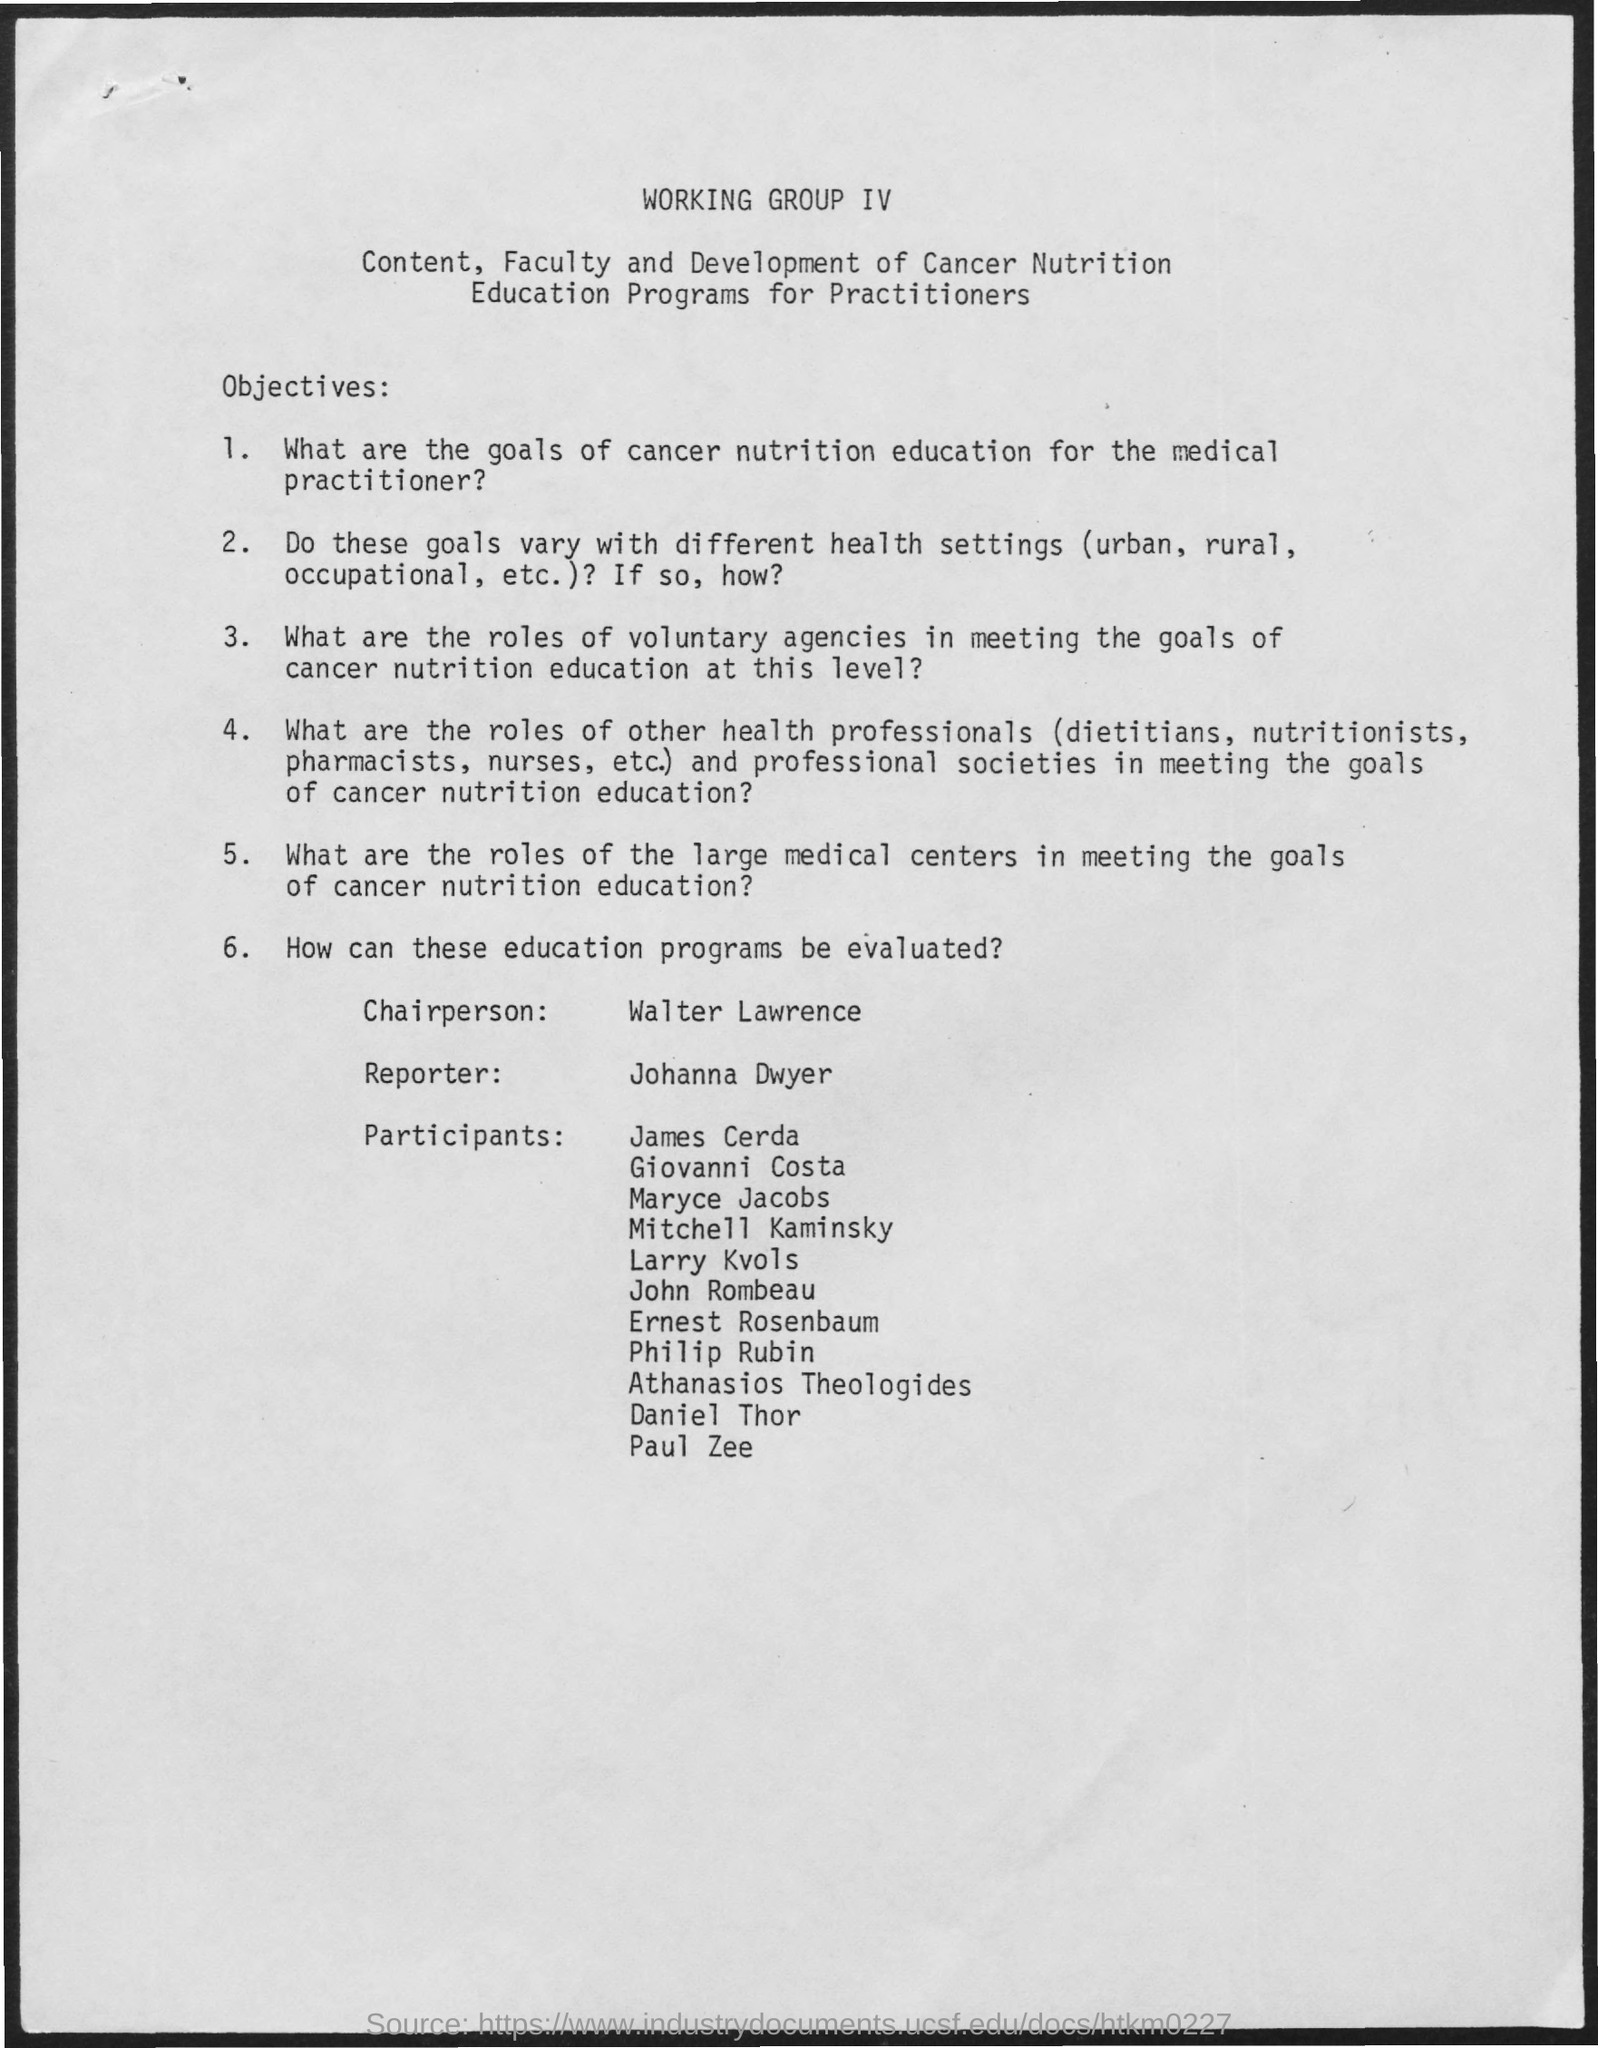What is the name of the chairperson mentioned in the given page ?
Provide a succinct answer. Walter Lawrence. What is the name of the reporter mentioned in the given page ?
Give a very brief answer. Johanna Dwyer. 